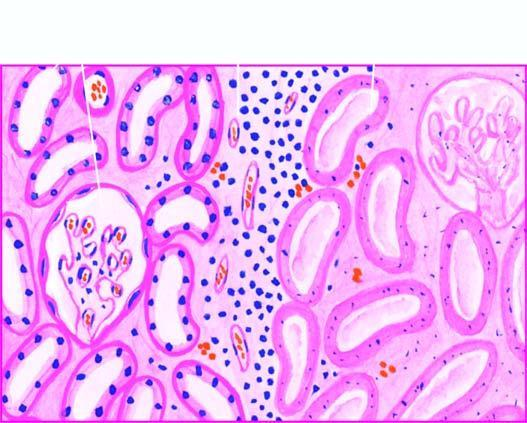what does the affected area on right show?
Answer the question using a single word or phrase. Cells with intensely eosinophilic cytoplasm of tubular cells 